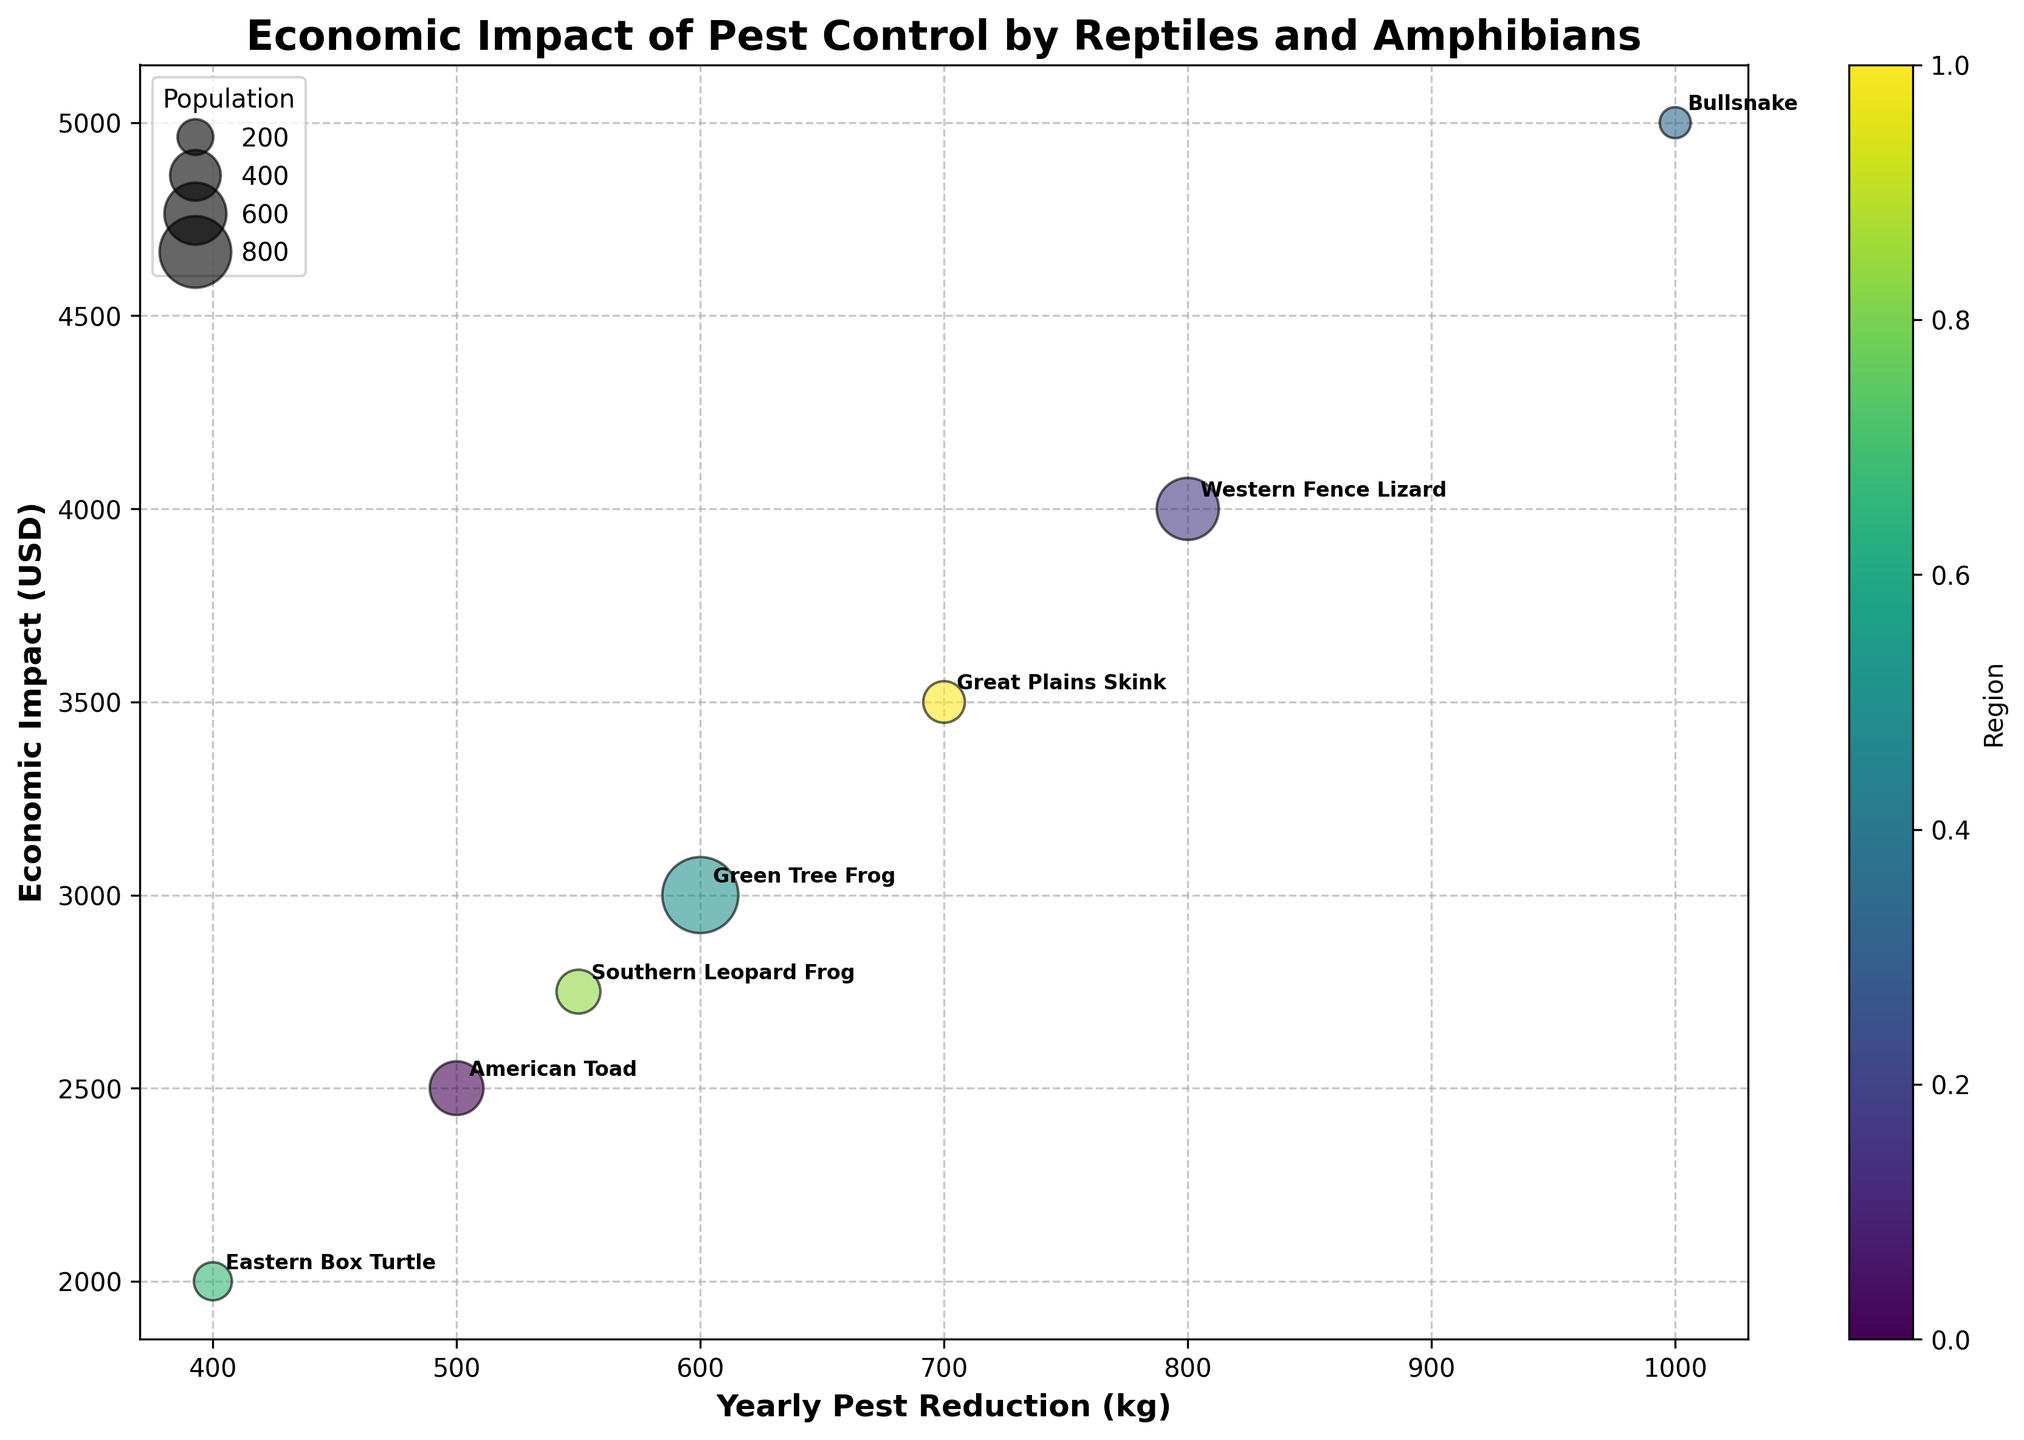What is the title of the chart? The title of the chart is typically positioned at the top of the figure. In this case, the title is prominently displayed.
Answer: Economic Impact of Pest Control by Reptiles and Amphibians How many data points are shown in the bubble chart? Each data point represents a combination of yearly pest reduction, economic impact, and population for a different reptile or amphibian. We can count the individual bubbles annotated with their names
Answer: 7 Which reptile or amphibian has the highest population? We identify the bubble size, which is proportional to the population. The largest bubble will represent the reptile or amphibian with the highest population.
Answer: Green Tree Frog What is the relationship between Yearly Pest Reduction and Economic Impact? By examining the overall trend of the bubbles in the chart, we can see if there's a pattern, such as an upward trend indicating that an increase in pest reduction generally leads to a higher economic impact.
Answer: Positive correlation Which reptile or amphibian shows the highest economic impact? We look for the bubble that is the farthest to the right on the x-axis, as this represents the maximum value of the “Economic Impact (USD)” axis.
Answer: Bullsnake How does the economic impact compare between the American Toad and the Western Fence Lizard? Locate the American Toad and Western Fence Lizard bubbles and compare their vertical positions on the “Economic Impact (USD)” axis. The Western Fence Lizard is slightly higher.
Answer: Western Fence Lizard has a higher impact What is the total yearly pest reduction for all the reptiles and amphibians combined? Add the Yearly Pest Reduction (kg) for all the data points: 500 + 800 + 1000 + 600 + 400 + 550 + 700
Answer: 4550 kg How does the population of the Eastern Box Turtle compare to that of the Great Plains Skink? Compare their bubble sizes (third variable 'Population'). Eastern Box Turtle bubble is slightly larger than Great Plains Skink.
Answer: Eastern Box Turtle has a higher population Which reptile or amphibian provides the least economic impact? Locate the bubble that is the lowest on the y-axis, indicating the minimum Economic Impact (USD).
Answer: Eastern Box Turtle What is the average economic impact among all the species? Sum the Economic Impact (USD) values and divide by the number of species: (2500 + 4000 + 5000 + 3000 + 2000 + 2750 + 3500) / 7
Answer: Approximately 3250 USD 